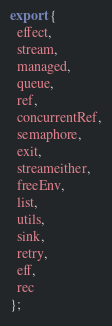<code> <loc_0><loc_0><loc_500><loc_500><_TypeScript_>export {
  effect,
  stream,
  managed,
  queue,
  ref,
  concurrentRef,
  semaphore,
  exit,
  streameither,
  freeEnv,
  list,
  utils,
  sink,
  retry,
  eff,
  rec
};
</code> 